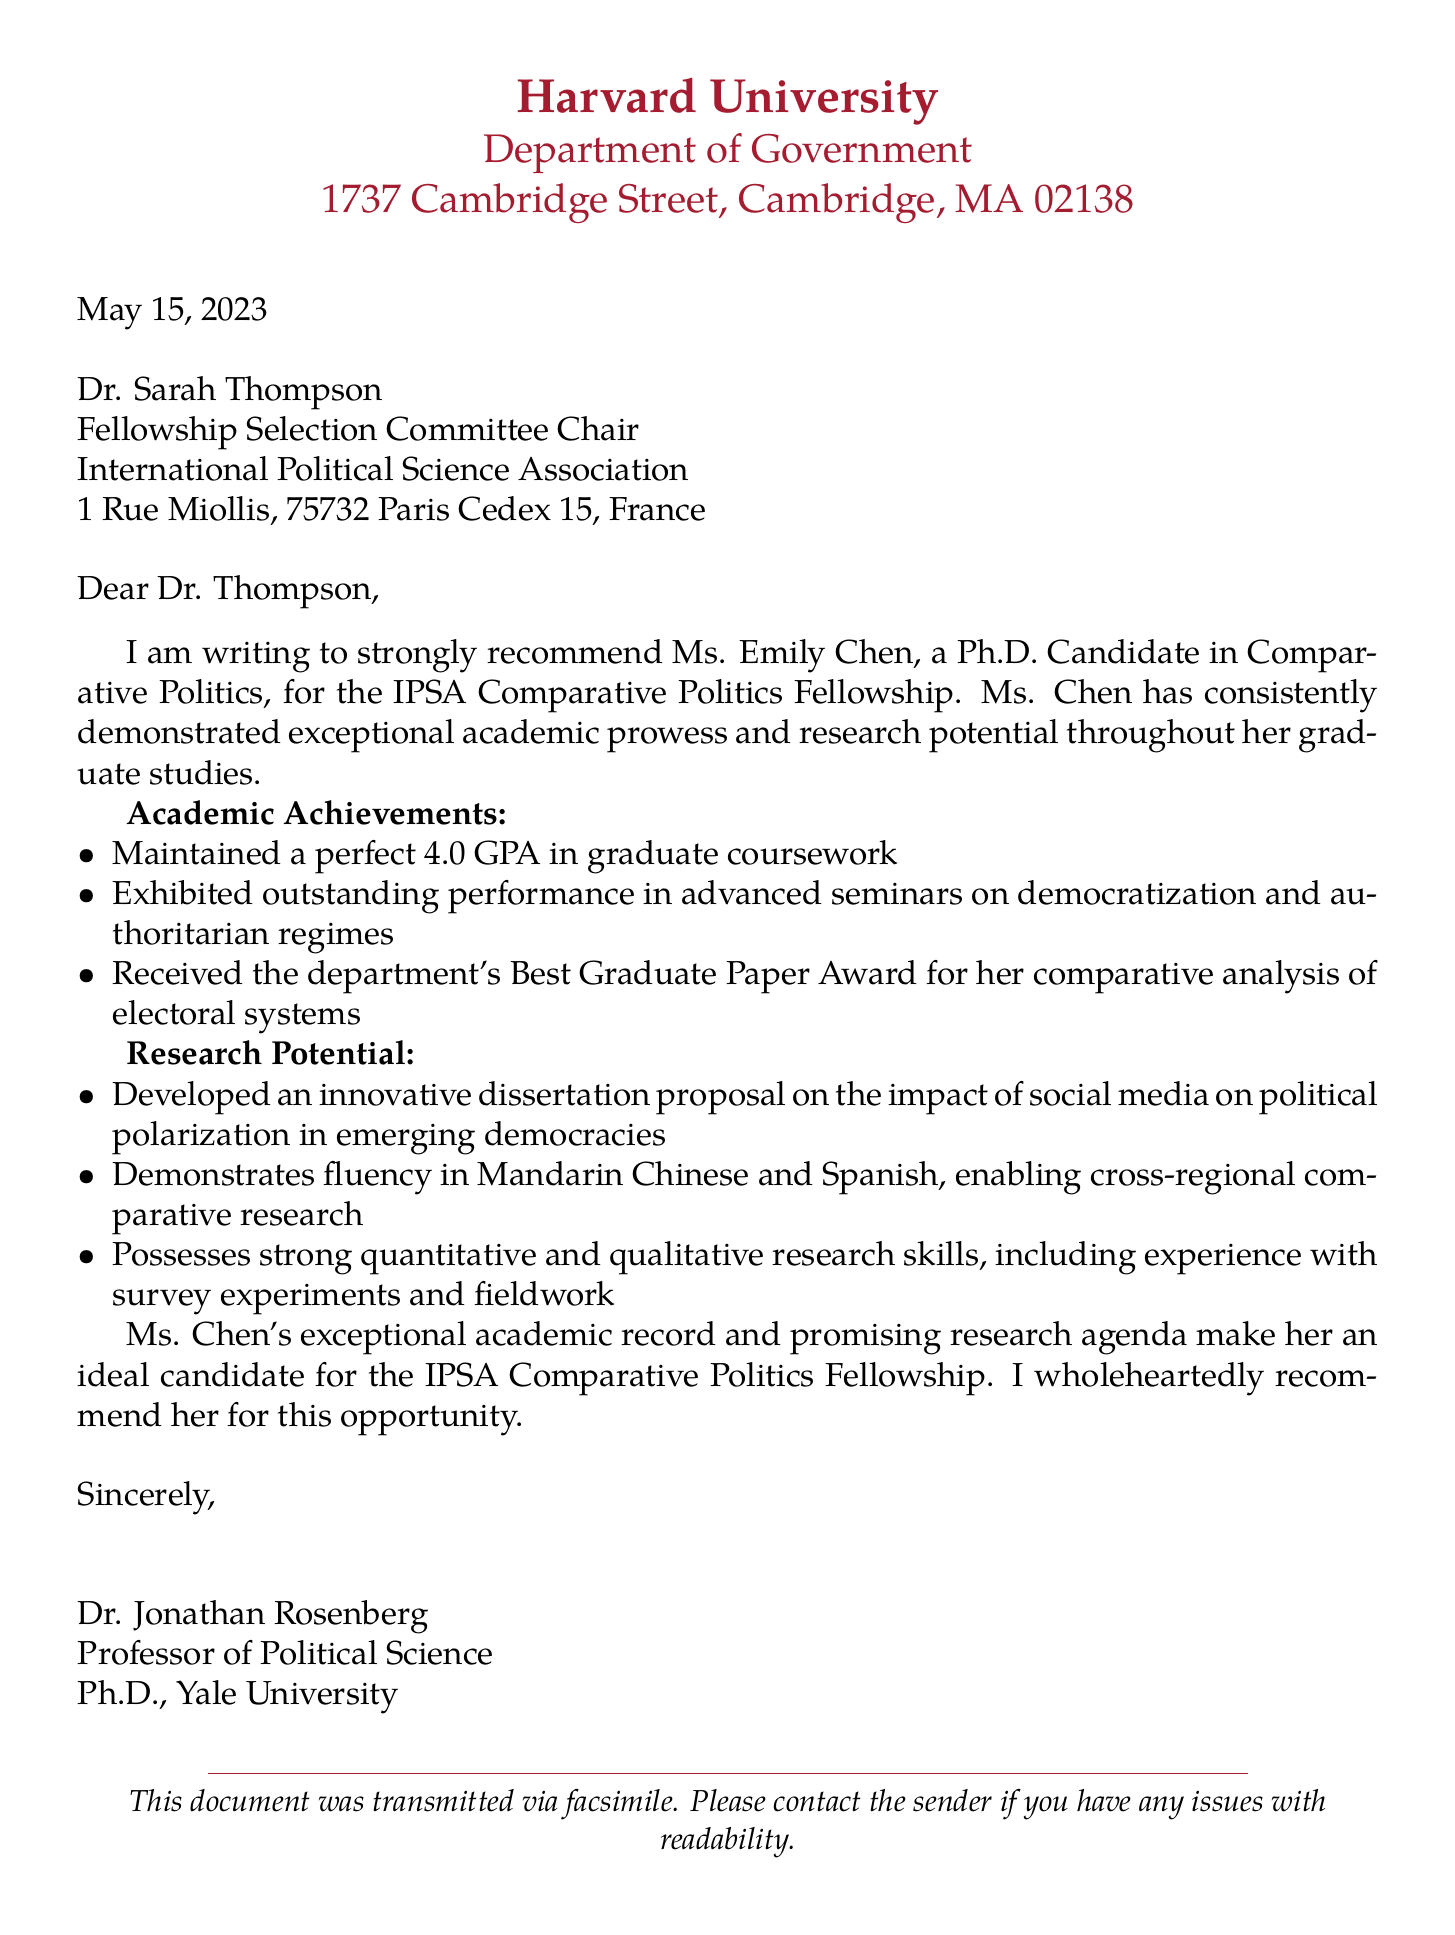What is the date of the fax? The date is indicated at the beginning of the document, specifically mentioned as May 15, 2023.
Answer: May 15, 2023 Who is the recipient of the letter? The recipient is named in the salutation of the letter, specifically Dr. Sarah Thompson.
Answer: Dr. Sarah Thompson What is Ms. Emily Chen's GPA? The document states her academic achievement with a perfect GPA, using a numerical format for clarity.
Answer: 4.0 What award did Ms. Chen receive? The document mentions that she received the department's Best Graduate Paper Award for her work.
Answer: Best Graduate Paper Award What is Ms. Chen's dissertation proposal about? The letter outlines the innovative topic of her dissertation, specifically focused on a contemporary issue in political science.
Answer: Impact of social media on political polarization in emerging democracies How many languages does Ms. Chen speak fluently? The document specifies her fluency in two languages, which is emphasized in her abilities for research.
Answer: Two Who is the recommender of Ms. Chen? The document concludes with the name of the recommender, which is present in the signature at the end.
Answer: Dr. Jonathan Rosenberg What is the affiliation of the recommender? The document indicates that the recommender holds a specific title and department role within a university context.
Answer: Professor of Political Science What type of document is this? The overall structure and purpose of the letter align with a formal recommendation for a specific opportunity.
Answer: Letter of recommendation 